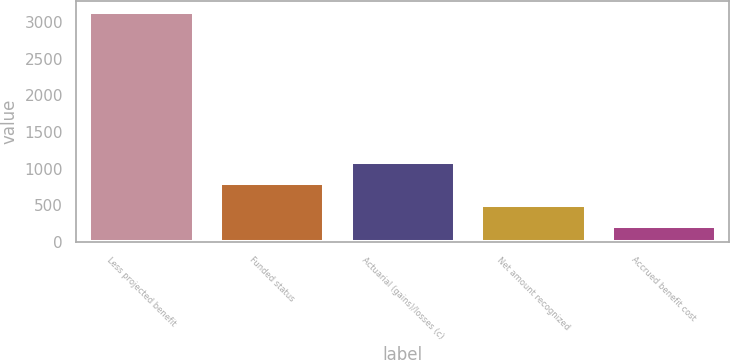<chart> <loc_0><loc_0><loc_500><loc_500><bar_chart><fcel>Less projected benefit<fcel>Funded status<fcel>Actuarial (gains)/losses (c)<fcel>Net amount recognized<fcel>Accrued benefit cost<nl><fcel>3130<fcel>799.6<fcel>1093<fcel>508.3<fcel>217<nl></chart> 